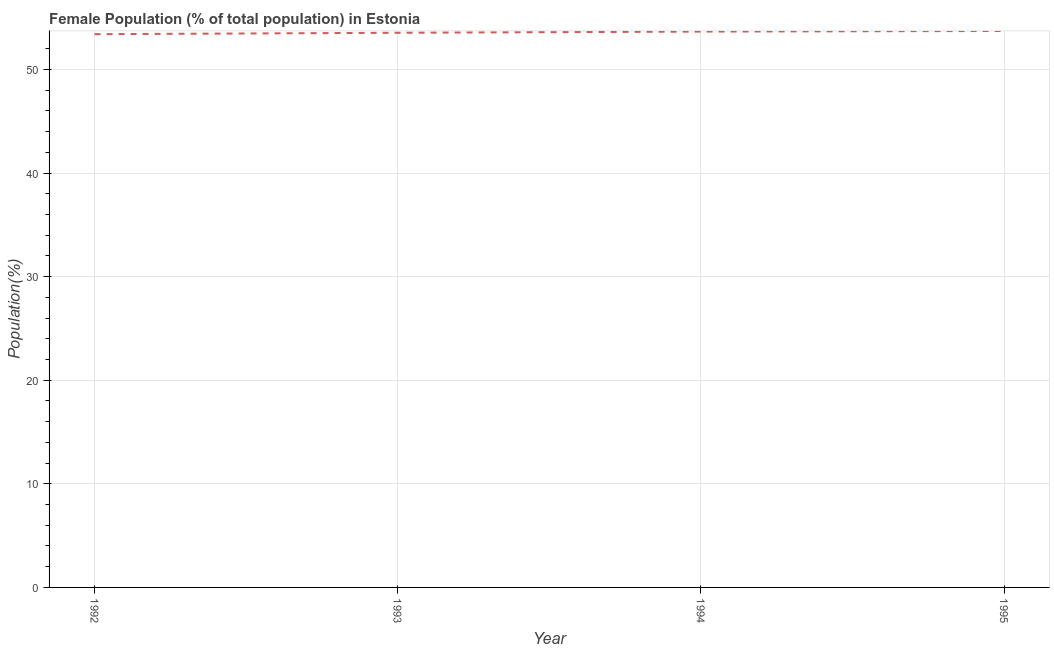What is the female population in 1995?
Keep it short and to the point. 53.72. Across all years, what is the maximum female population?
Make the answer very short. 53.72. Across all years, what is the minimum female population?
Give a very brief answer. 53.41. In which year was the female population maximum?
Provide a short and direct response. 1995. In which year was the female population minimum?
Give a very brief answer. 1992. What is the sum of the female population?
Offer a terse response. 214.34. What is the difference between the female population in 1993 and 1995?
Provide a short and direct response. -0.17. What is the average female population per year?
Offer a terse response. 53.58. What is the median female population?
Give a very brief answer. 53.6. Do a majority of the years between 1993 and 1994 (inclusive) have female population greater than 32 %?
Offer a very short reply. Yes. What is the ratio of the female population in 1992 to that in 1993?
Ensure brevity in your answer.  1. What is the difference between the highest and the second highest female population?
Provide a short and direct response. 0.06. What is the difference between the highest and the lowest female population?
Provide a succinct answer. 0.31. In how many years, is the female population greater than the average female population taken over all years?
Provide a succinct answer. 2. Does the female population monotonically increase over the years?
Provide a succinct answer. Yes. How many lines are there?
Keep it short and to the point. 1. What is the difference between two consecutive major ticks on the Y-axis?
Ensure brevity in your answer.  10. Are the values on the major ticks of Y-axis written in scientific E-notation?
Give a very brief answer. No. What is the title of the graph?
Your response must be concise. Female Population (% of total population) in Estonia. What is the label or title of the X-axis?
Give a very brief answer. Year. What is the label or title of the Y-axis?
Provide a succinct answer. Population(%). What is the Population(%) in 1992?
Offer a very short reply. 53.41. What is the Population(%) in 1993?
Your answer should be very brief. 53.55. What is the Population(%) of 1994?
Give a very brief answer. 53.66. What is the Population(%) of 1995?
Make the answer very short. 53.72. What is the difference between the Population(%) in 1992 and 1993?
Ensure brevity in your answer.  -0.13. What is the difference between the Population(%) in 1992 and 1994?
Your answer should be very brief. -0.25. What is the difference between the Population(%) in 1992 and 1995?
Your answer should be compact. -0.31. What is the difference between the Population(%) in 1993 and 1994?
Make the answer very short. -0.11. What is the difference between the Population(%) in 1993 and 1995?
Provide a short and direct response. -0.17. What is the difference between the Population(%) in 1994 and 1995?
Keep it short and to the point. -0.06. What is the ratio of the Population(%) in 1992 to that in 1994?
Offer a very short reply. 0.99. What is the ratio of the Population(%) in 1992 to that in 1995?
Provide a short and direct response. 0.99. 